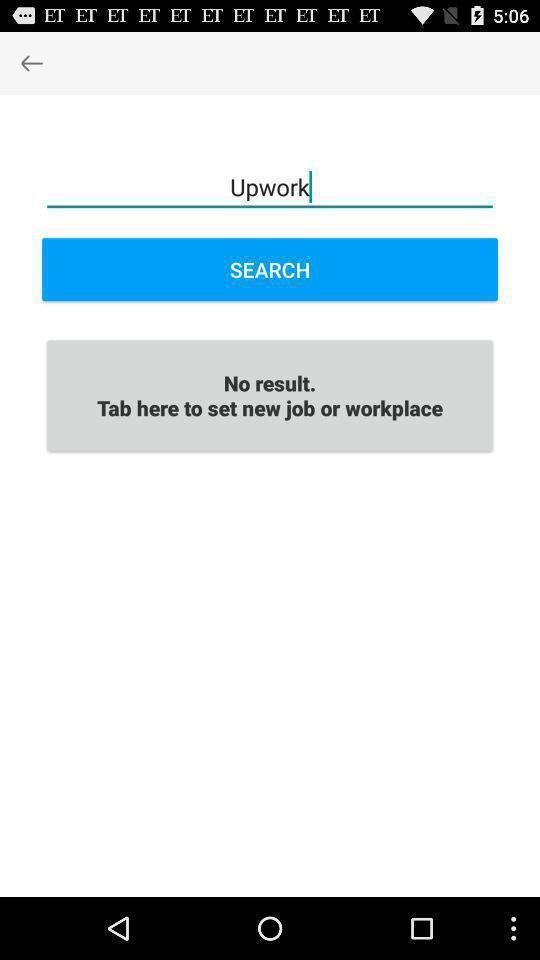Provide a description of this screenshot. Screen showing search option. 